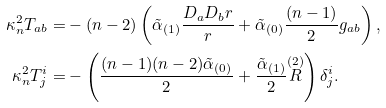Convert formula to latex. <formula><loc_0><loc_0><loc_500><loc_500>\kappa _ { n } ^ { 2 } T _ { a b } = & - ( n - 2 ) \left ( { \tilde { \alpha } } _ { ( 1 ) } \frac { D _ { a } D _ { b } r } { r } + { \tilde { \alpha } } _ { ( 0 ) } \frac { ( n - 1 ) } { 2 } g _ { a b } \right ) , \\ \kappa _ { n } ^ { 2 } T ^ { i } _ { j } = & - \left ( \frac { ( n - 1 ) ( n - 2 ) { \tilde { \alpha } } _ { ( 0 ) } } { 2 } + \frac { { \tilde { \alpha } } _ { ( 1 ) } } { 2 } \overset { ( 2 ) } { R } \right ) \delta ^ { i } _ { j } .</formula> 